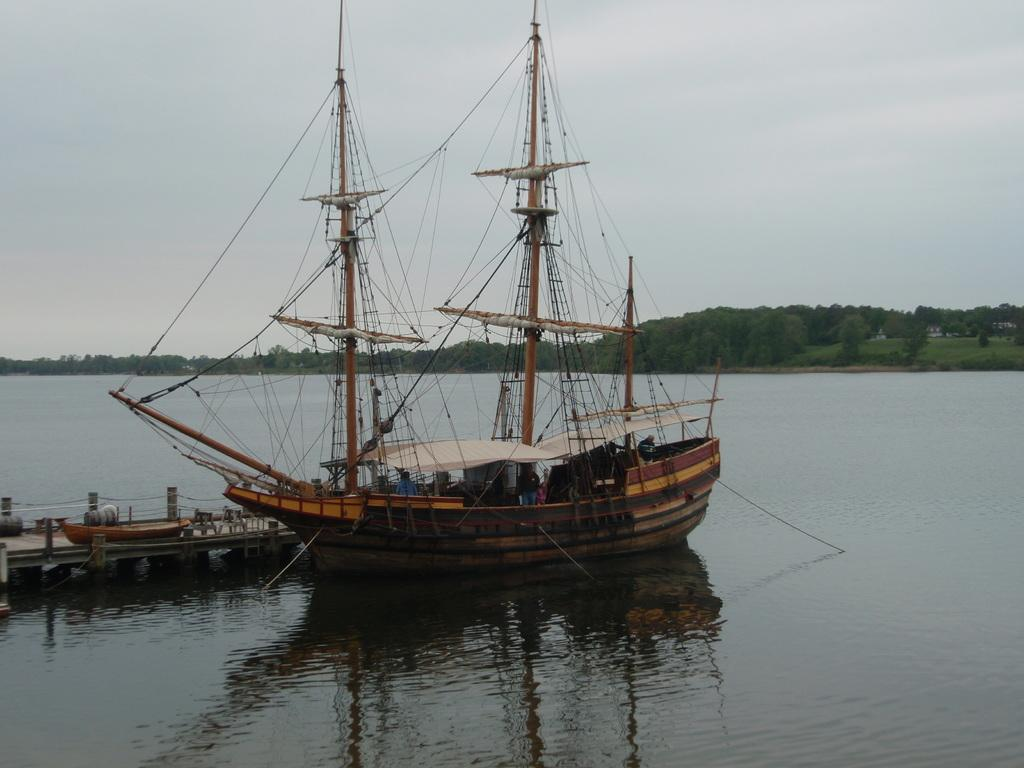What is the main subject of the image? The main subject of the image is a ship. What is the ship located near in the image? There is a dock in the image. Where are the ship and dock situated? The ship and dock are on the water surface. What can be seen in the background of the image? There are trees and the sky visible in the background of the image. Can you tell me how many kittens are playing with the print on the ship's deck in the image? There are no kittens or prints present on the ship's deck in the image. What type of journey is the ship embarking on in the image? The image does not provide any information about the ship's journey; it only shows the ship and dock on the water surface. 